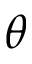Convert formula to latex. <formula><loc_0><loc_0><loc_500><loc_500>\theta</formula> 